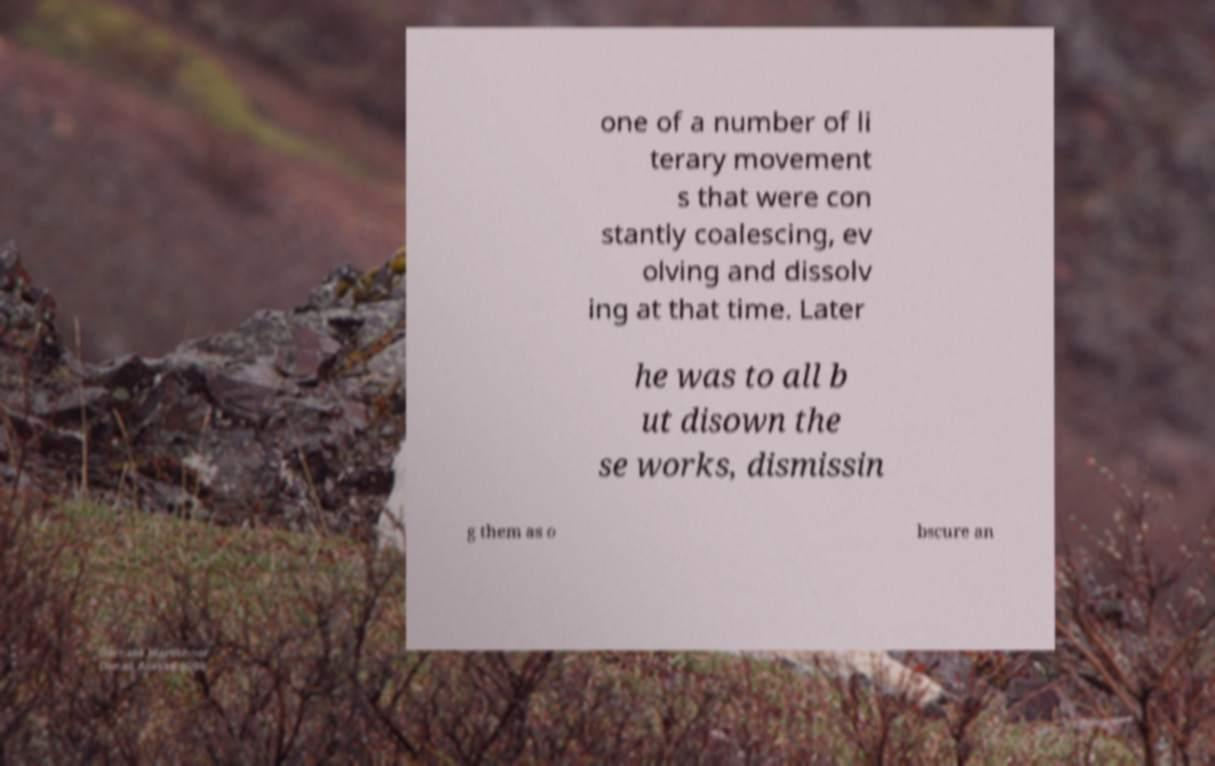Please read and relay the text visible in this image. What does it say? one of a number of li terary movement s that were con stantly coalescing, ev olving and dissolv ing at that time. Later he was to all b ut disown the se works, dismissin g them as o bscure an 